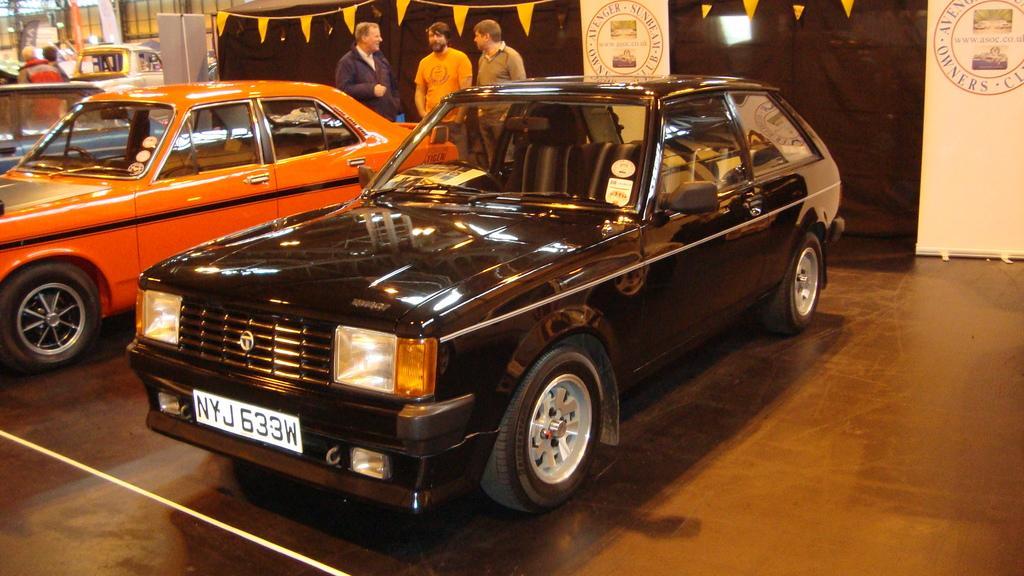In one or two sentences, can you explain what this image depicts? In this picture we can see cars and some persons standing on the ground and in the background we can see banners, flags. 